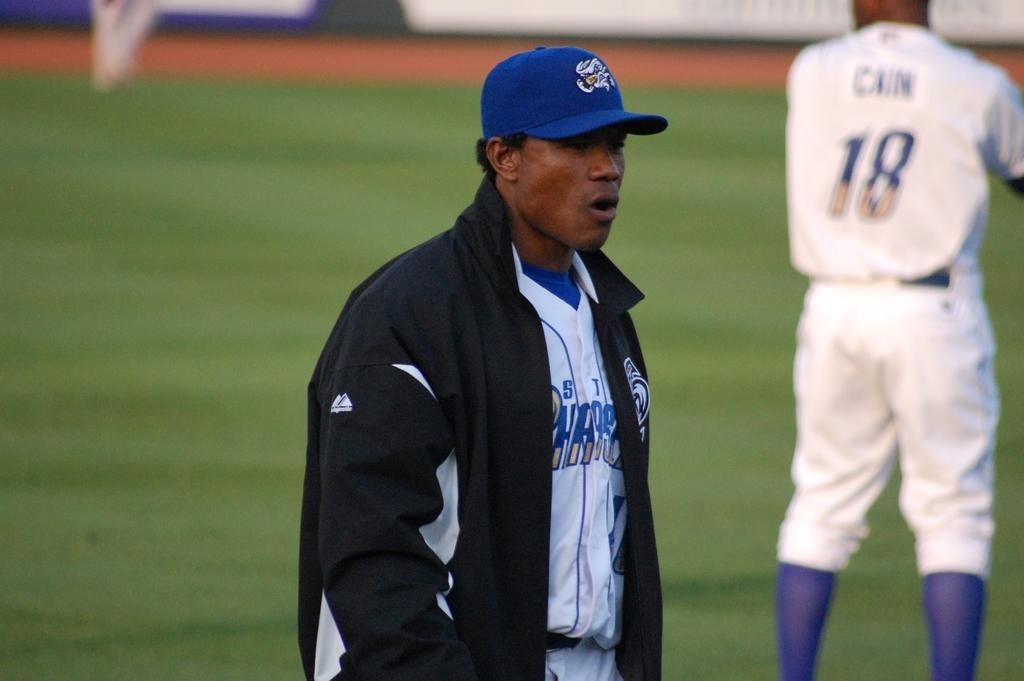Provide a one-sentence caption for the provided image. Baseball player wearing number 18 getting ready to pitch. 